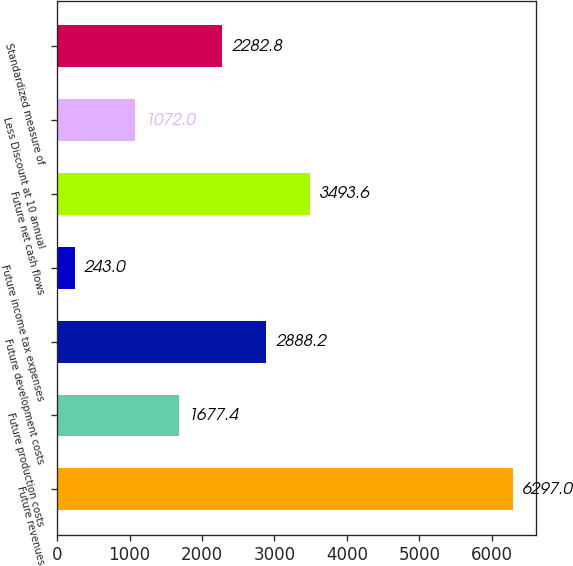<chart> <loc_0><loc_0><loc_500><loc_500><bar_chart><fcel>Future revenues<fcel>Future production costs<fcel>Future development costs<fcel>Future income tax expenses<fcel>Future net cash flows<fcel>Less Discount at 10 annual<fcel>Standardized measure of<nl><fcel>6297<fcel>1677.4<fcel>2888.2<fcel>243<fcel>3493.6<fcel>1072<fcel>2282.8<nl></chart> 